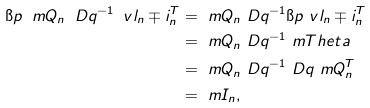Convert formula to latex. <formula><loc_0><loc_0><loc_500><loc_500>\i p { \ m Q _ { n } \ D q ^ { - 1 } \ v l _ { n } \mp i _ { n } ^ { T } } & = \ m Q _ { n } \ D q ^ { - 1 } \i p { \ v l _ { n } \mp i _ { n } ^ { T } } \\ & = \ m Q _ { n } \ D q ^ { - 1 } \ m T h e t a \\ & = \ m Q _ { n } \ D q ^ { - 1 } \ D q \ m Q _ { n } ^ { T } \\ & = \ m I _ { n } ,</formula> 